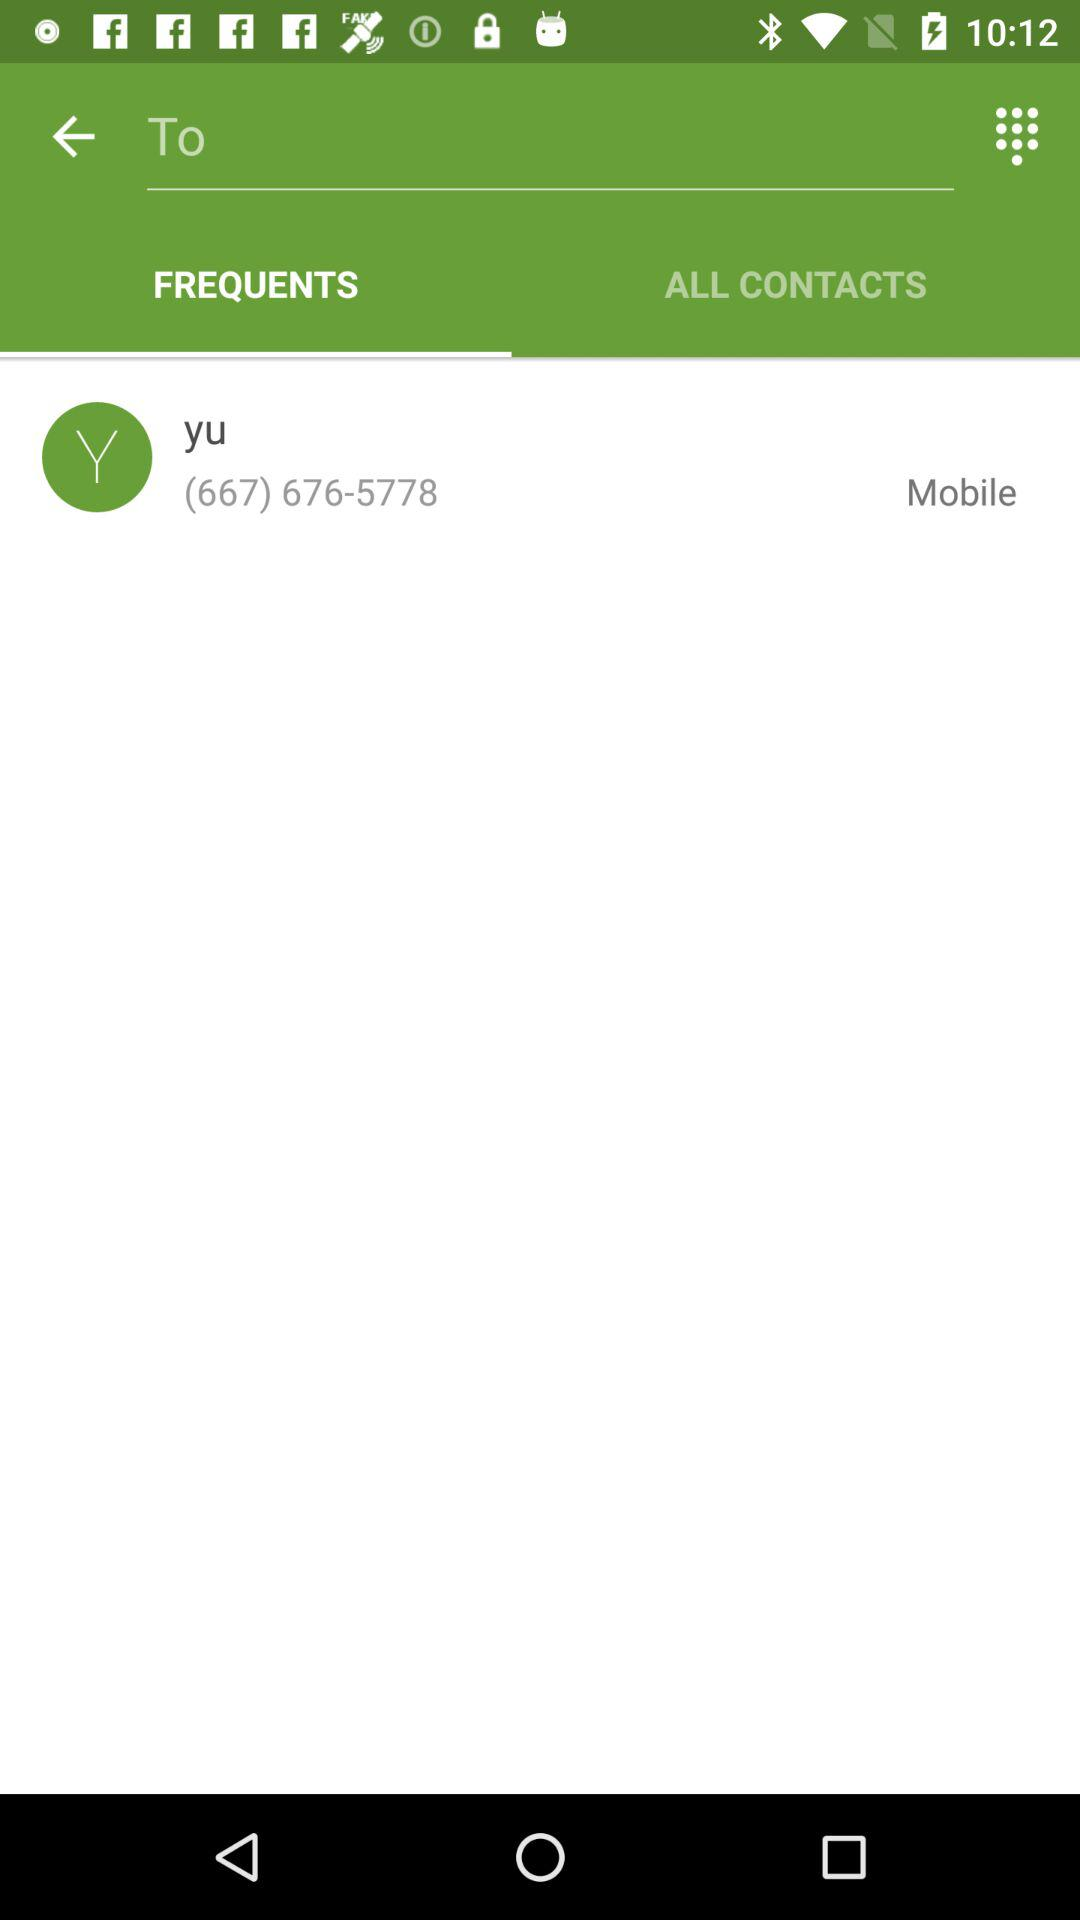How many digits are there in the contact's phone number?
Answer the question using a single word or phrase. 10 